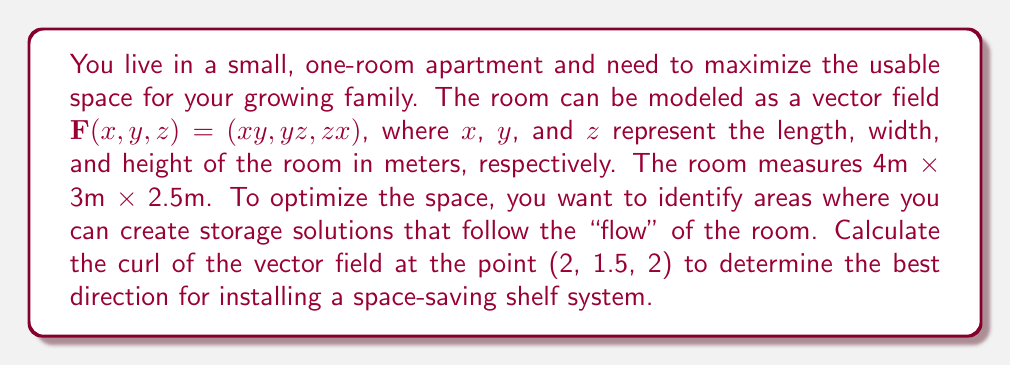Can you answer this question? To solve this problem, we need to follow these steps:

1) The curl of a vector field $\mathbf{F}(x,y,z) = (P, Q, R)$ is defined as:

   $$\text{curl}\,\mathbf{F} = \nabla \times \mathbf{F} = \left(\frac{\partial R}{\partial y} - \frac{\partial Q}{\partial z}, \frac{\partial P}{\partial z} - \frac{\partial R}{\partial x}, \frac{\partial Q}{\partial x} - \frac{\partial P}{\partial y}\right)$$

2) In our case, $\mathbf{F}(x,y,z) = (xy, yz, zx)$, so:
   $P = xy$, $Q = yz$, $R = zx$

3) Let's calculate each component of the curl:

   $\frac{\partial R}{\partial y} - \frac{\partial Q}{\partial z} = 0 - y = -y$
   
   $\frac{\partial P}{\partial z} - \frac{\partial R}{\partial x} = 0 - z = -z$
   
   $\frac{\partial Q}{\partial x} - \frac{\partial P}{\partial y} = 0 - x = -x$

4) Therefore, the curl of $\mathbf{F}$ is:

   $$\text{curl}\,\mathbf{F} = (-y, -z, -x)$$

5) Now, we need to evaluate this at the point (2, 1.5, 2):

   $$\text{curl}\,\mathbf{F}(2, 1.5, 2) = (-1.5, -2, -2)$$

This result indicates the direction and magnitude of the maximum circulation of the vector field at the given point. The negative values suggest that the optimal direction for the shelf system would be opposite to these components.
Answer: The curl of the vector field at the point (2, 1.5, 2) is $(-1.5, -2, -2)$. This means the most efficient direction for installing a space-saving shelf system would be $(1.5, 2, 2)$, which is opposite to the curl vector. 